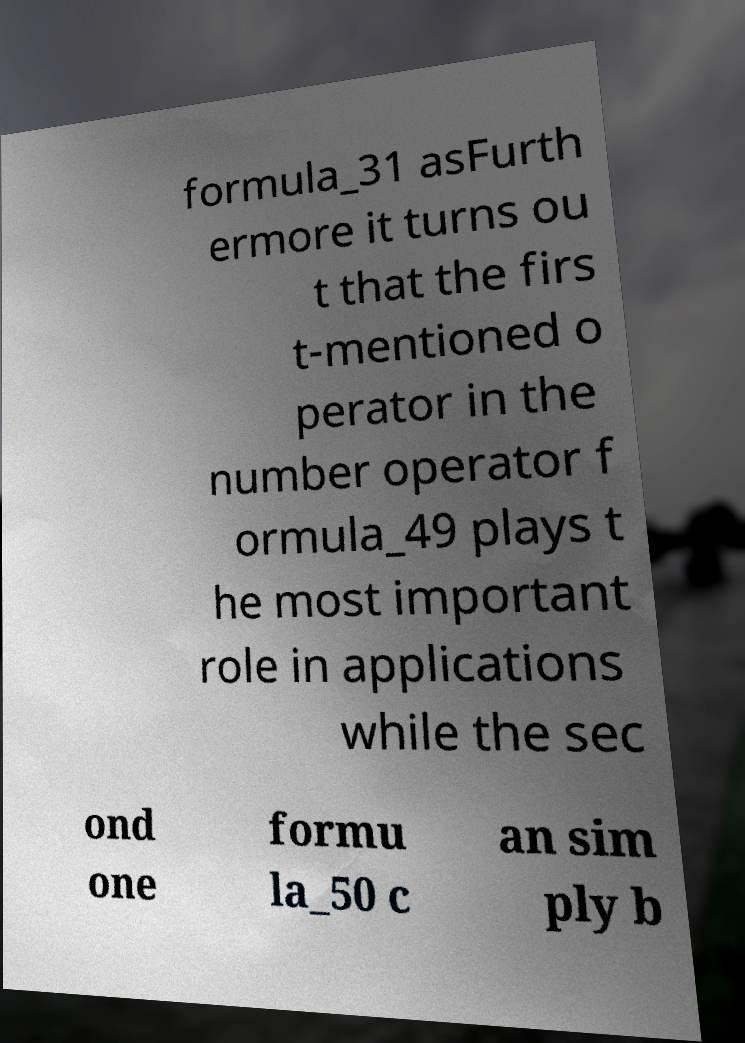What messages or text are displayed in this image? I need them in a readable, typed format. formula_31 asFurth ermore it turns ou t that the firs t-mentioned o perator in the number operator f ormula_49 plays t he most important role in applications while the sec ond one formu la_50 c an sim ply b 